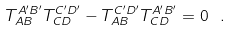<formula> <loc_0><loc_0><loc_500><loc_500>T _ { A B } ^ { A ^ { \prime } B ^ { \prime } } T _ { C D } ^ { C ^ { \prime } D ^ { \prime } } - T _ { A B } ^ { C ^ { \prime } D ^ { \prime } } T _ { C D } ^ { A ^ { \prime } B ^ { \prime } } = 0 \ .</formula> 